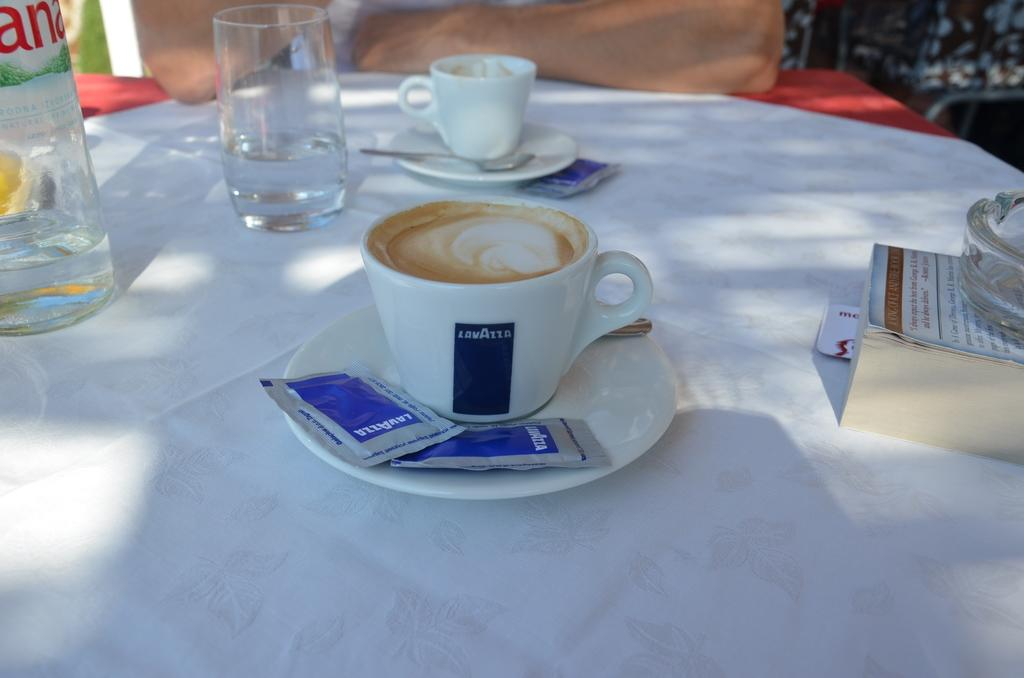What type of furniture is present in the image? There is a table in the image. What is placed on the table? There is a cup, a glass, and a water bottle on the table. What type of mark can be seen on the knee of the person in the image? There is no person present in the image, so it is not possible to determine if there is a mark on their knee. 